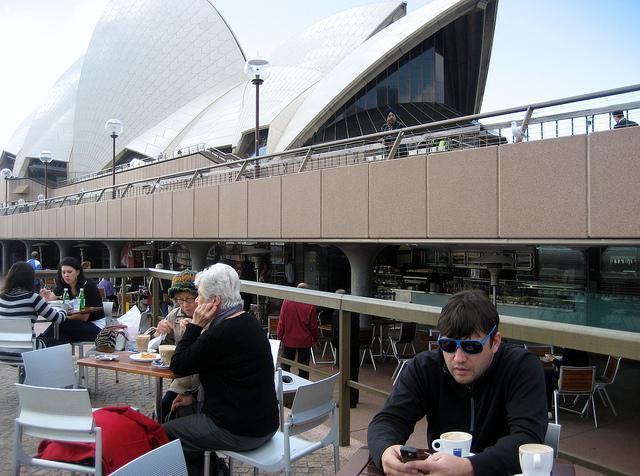What type of entertainment is commonly held in the building behind the people eating?
From the following set of four choices, select the accurate answer to respond to the question.
Options: Movies, opera, standup comedy, hockey. Opera. 